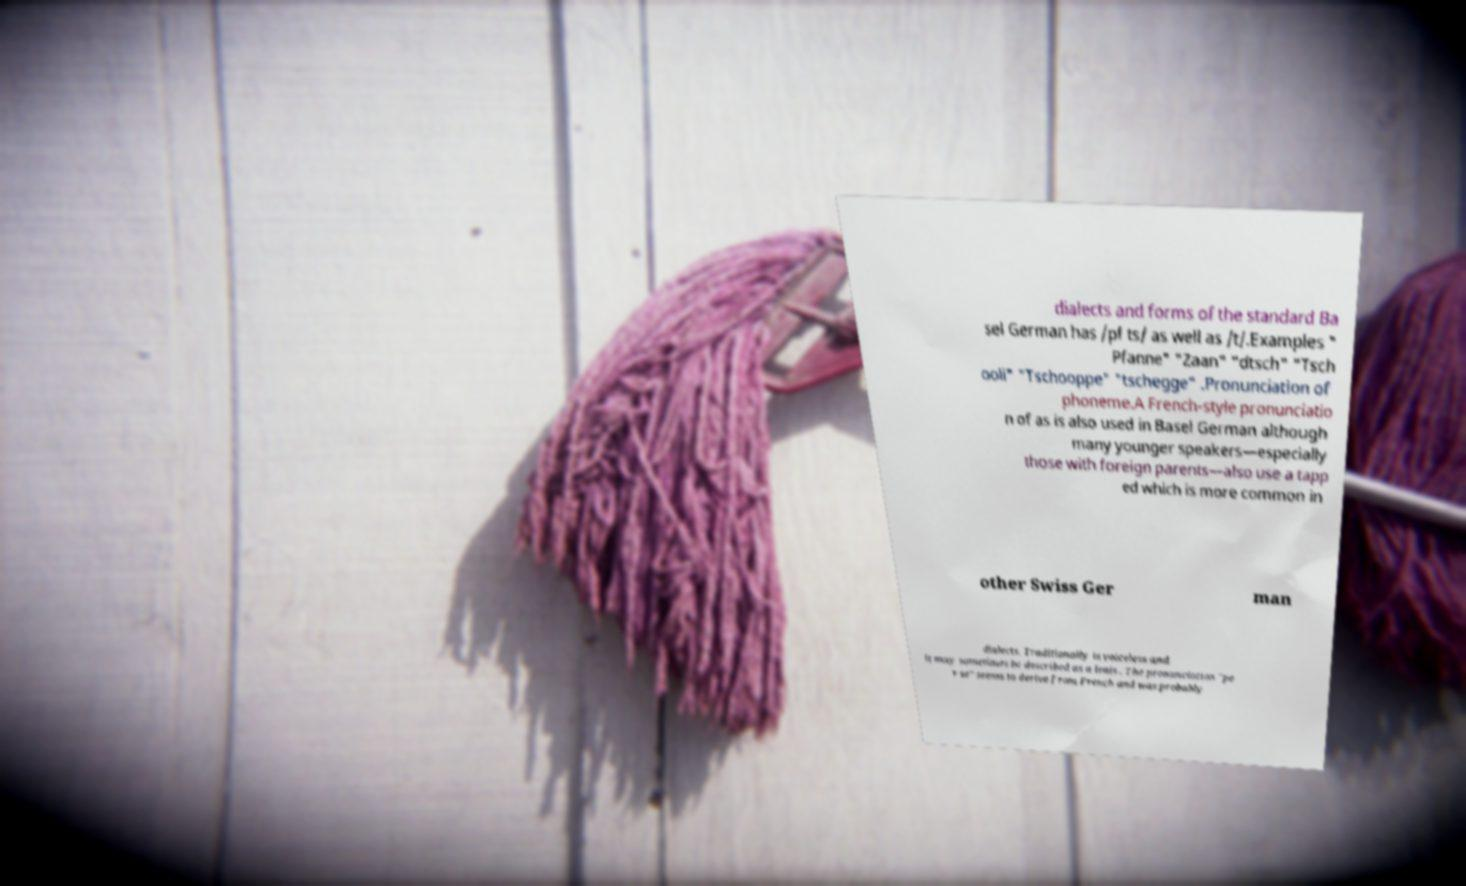Please identify and transcribe the text found in this image. dialects and forms of the standard Ba sel German has /pf ts/ as well as /t/.Examples " Pfanne" "Zaan" "dtsch" "Tsch ooli" "Tschooppe" "tschegge" .Pronunciation of phoneme.A French-style pronunciatio n of as is also used in Basel German although many younger speakers—especially those with foreign parents—also use a tapp ed which is more common in other Swiss Ger man dialects. Traditionally is voiceless and it may sometimes be described as a lenis . The pronunciation "pe r se" seems to derive from French and was probably 